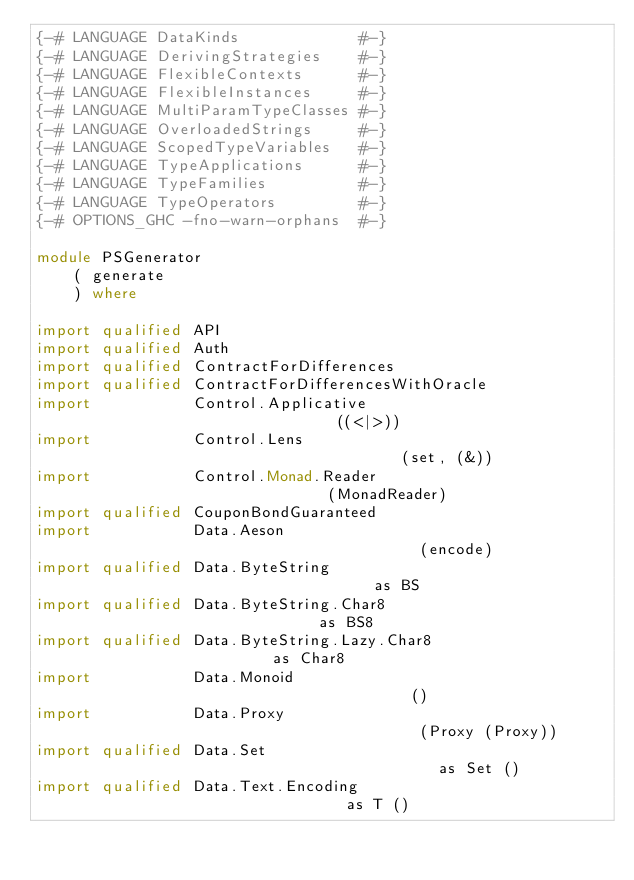Convert code to text. <code><loc_0><loc_0><loc_500><loc_500><_Haskell_>{-# LANGUAGE DataKinds             #-}
{-# LANGUAGE DerivingStrategies    #-}
{-# LANGUAGE FlexibleContexts      #-}
{-# LANGUAGE FlexibleInstances     #-}
{-# LANGUAGE MultiParamTypeClasses #-}
{-# LANGUAGE OverloadedStrings     #-}
{-# LANGUAGE ScopedTypeVariables   #-}
{-# LANGUAGE TypeApplications      #-}
{-# LANGUAGE TypeFamilies          #-}
{-# LANGUAGE TypeOperators         #-}
{-# OPTIONS_GHC -fno-warn-orphans  #-}

module PSGenerator
    ( generate
    ) where

import qualified API
import qualified Auth
import qualified ContractForDifferences
import qualified ContractForDifferencesWithOracle
import           Control.Applicative                              ((<|>))
import           Control.Lens                                     (set, (&))
import           Control.Monad.Reader                             (MonadReader)
import qualified CouponBondGuaranteed
import           Data.Aeson                                       (encode)
import qualified Data.ByteString                                  as BS
import qualified Data.ByteString.Char8                            as BS8
import qualified Data.ByteString.Lazy.Char8                       as Char8
import           Data.Monoid                                      ()
import           Data.Proxy                                       (Proxy (Proxy))
import qualified Data.Set                                         as Set ()
import qualified Data.Text.Encoding                               as T ()</code> 